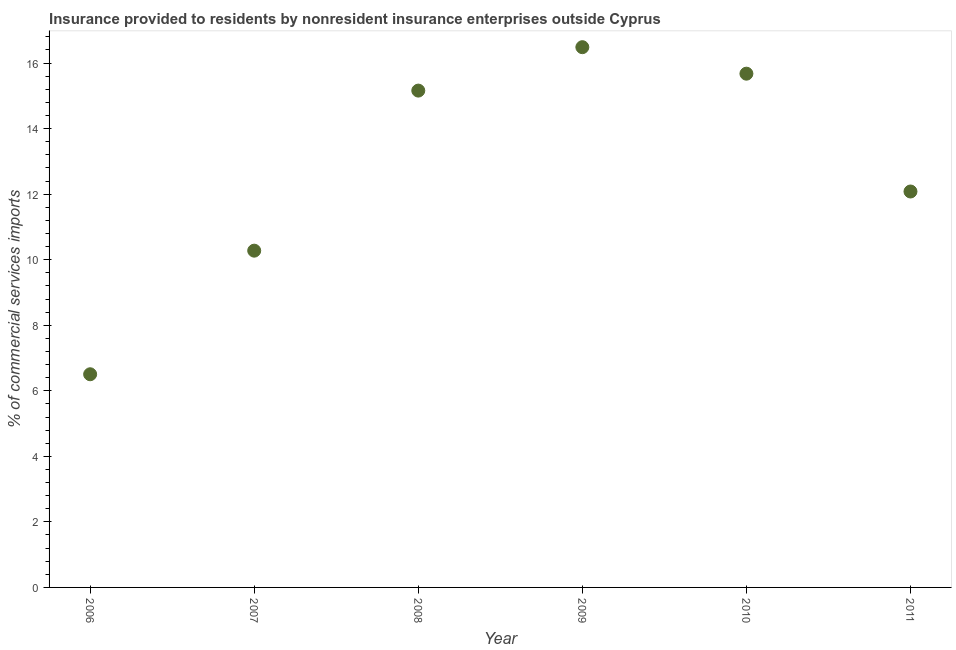What is the insurance provided by non-residents in 2007?
Provide a short and direct response. 10.28. Across all years, what is the maximum insurance provided by non-residents?
Provide a short and direct response. 16.48. Across all years, what is the minimum insurance provided by non-residents?
Keep it short and to the point. 6.5. In which year was the insurance provided by non-residents minimum?
Your response must be concise. 2006. What is the sum of the insurance provided by non-residents?
Provide a short and direct response. 76.18. What is the difference between the insurance provided by non-residents in 2007 and 2008?
Offer a terse response. -4.88. What is the average insurance provided by non-residents per year?
Keep it short and to the point. 12.7. What is the median insurance provided by non-residents?
Your answer should be very brief. 13.62. What is the ratio of the insurance provided by non-residents in 2008 to that in 2010?
Provide a short and direct response. 0.97. Is the insurance provided by non-residents in 2009 less than that in 2011?
Give a very brief answer. No. What is the difference between the highest and the second highest insurance provided by non-residents?
Offer a very short reply. 0.81. What is the difference between the highest and the lowest insurance provided by non-residents?
Give a very brief answer. 9.98. Does the insurance provided by non-residents monotonically increase over the years?
Offer a very short reply. No. How many dotlines are there?
Provide a short and direct response. 1. What is the difference between two consecutive major ticks on the Y-axis?
Your answer should be very brief. 2. Are the values on the major ticks of Y-axis written in scientific E-notation?
Ensure brevity in your answer.  No. Does the graph contain any zero values?
Your response must be concise. No. What is the title of the graph?
Offer a terse response. Insurance provided to residents by nonresident insurance enterprises outside Cyprus. What is the label or title of the X-axis?
Your answer should be very brief. Year. What is the label or title of the Y-axis?
Provide a short and direct response. % of commercial services imports. What is the % of commercial services imports in 2006?
Keep it short and to the point. 6.5. What is the % of commercial services imports in 2007?
Your answer should be compact. 10.28. What is the % of commercial services imports in 2008?
Your response must be concise. 15.16. What is the % of commercial services imports in 2009?
Your answer should be very brief. 16.48. What is the % of commercial services imports in 2010?
Offer a very short reply. 15.68. What is the % of commercial services imports in 2011?
Give a very brief answer. 12.08. What is the difference between the % of commercial services imports in 2006 and 2007?
Your answer should be very brief. -3.77. What is the difference between the % of commercial services imports in 2006 and 2008?
Your response must be concise. -8.65. What is the difference between the % of commercial services imports in 2006 and 2009?
Your answer should be very brief. -9.98. What is the difference between the % of commercial services imports in 2006 and 2010?
Give a very brief answer. -9.17. What is the difference between the % of commercial services imports in 2006 and 2011?
Give a very brief answer. -5.58. What is the difference between the % of commercial services imports in 2007 and 2008?
Make the answer very short. -4.88. What is the difference between the % of commercial services imports in 2007 and 2009?
Make the answer very short. -6.21. What is the difference between the % of commercial services imports in 2007 and 2010?
Provide a succinct answer. -5.4. What is the difference between the % of commercial services imports in 2007 and 2011?
Provide a short and direct response. -1.81. What is the difference between the % of commercial services imports in 2008 and 2009?
Ensure brevity in your answer.  -1.32. What is the difference between the % of commercial services imports in 2008 and 2010?
Give a very brief answer. -0.52. What is the difference between the % of commercial services imports in 2008 and 2011?
Provide a short and direct response. 3.08. What is the difference between the % of commercial services imports in 2009 and 2010?
Your answer should be compact. 0.81. What is the difference between the % of commercial services imports in 2009 and 2011?
Ensure brevity in your answer.  4.4. What is the difference between the % of commercial services imports in 2010 and 2011?
Keep it short and to the point. 3.6. What is the ratio of the % of commercial services imports in 2006 to that in 2007?
Provide a succinct answer. 0.63. What is the ratio of the % of commercial services imports in 2006 to that in 2008?
Make the answer very short. 0.43. What is the ratio of the % of commercial services imports in 2006 to that in 2009?
Give a very brief answer. 0.4. What is the ratio of the % of commercial services imports in 2006 to that in 2010?
Your answer should be very brief. 0.41. What is the ratio of the % of commercial services imports in 2006 to that in 2011?
Your answer should be very brief. 0.54. What is the ratio of the % of commercial services imports in 2007 to that in 2008?
Offer a very short reply. 0.68. What is the ratio of the % of commercial services imports in 2007 to that in 2009?
Provide a succinct answer. 0.62. What is the ratio of the % of commercial services imports in 2007 to that in 2010?
Provide a short and direct response. 0.66. What is the ratio of the % of commercial services imports in 2007 to that in 2011?
Provide a succinct answer. 0.85. What is the ratio of the % of commercial services imports in 2008 to that in 2009?
Your answer should be very brief. 0.92. What is the ratio of the % of commercial services imports in 2008 to that in 2010?
Offer a terse response. 0.97. What is the ratio of the % of commercial services imports in 2008 to that in 2011?
Provide a short and direct response. 1.25. What is the ratio of the % of commercial services imports in 2009 to that in 2010?
Provide a succinct answer. 1.05. What is the ratio of the % of commercial services imports in 2009 to that in 2011?
Your response must be concise. 1.36. What is the ratio of the % of commercial services imports in 2010 to that in 2011?
Ensure brevity in your answer.  1.3. 